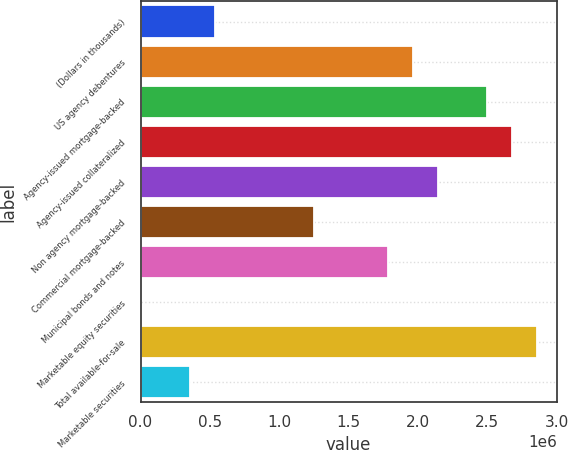<chart> <loc_0><loc_0><loc_500><loc_500><bar_chart><fcel>(Dollars in thousands)<fcel>US agency debentures<fcel>Agency-issued mortgage-backed<fcel>Agency-issued collateralized<fcel>Non agency mortgage-backed<fcel>Commercial mortgage-backed<fcel>Municipal bonds and notes<fcel>Marketable equity securities<fcel>Total available-for-sale<fcel>Marketable securities<nl><fcel>535936<fcel>1.96469e+06<fcel>2.50048e+06<fcel>2.67907e+06<fcel>2.14329e+06<fcel>1.25032e+06<fcel>1.7861e+06<fcel>152<fcel>2.85767e+06<fcel>357342<nl></chart> 